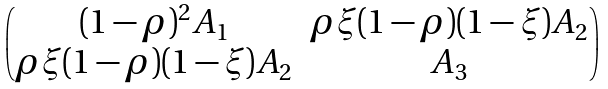<formula> <loc_0><loc_0><loc_500><loc_500>\begin{pmatrix} ( 1 - \rho ) ^ { 2 } A _ { 1 } & \rho \xi ( 1 - \rho ) ( 1 - \xi ) A _ { 2 } \\ \rho \xi ( 1 - \rho ) ( 1 - \xi ) A _ { 2 } & A _ { 3 } \\ \end{pmatrix}</formula> 